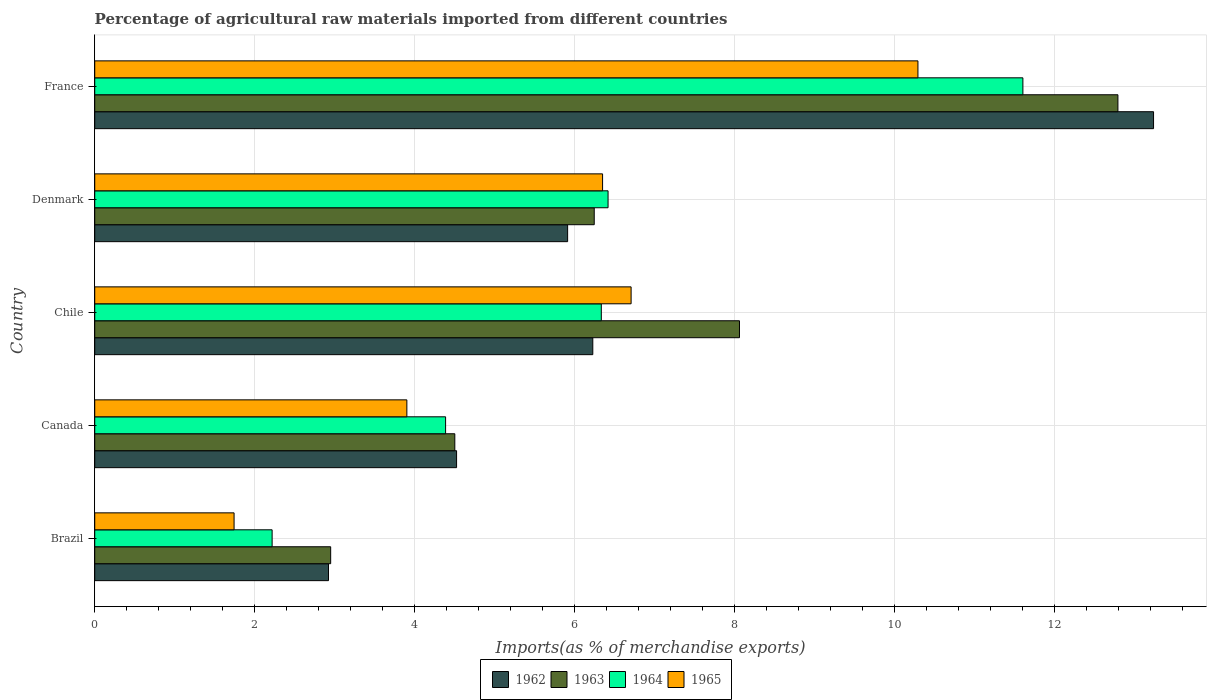How many different coloured bars are there?
Your answer should be very brief. 4. In how many cases, is the number of bars for a given country not equal to the number of legend labels?
Keep it short and to the point. 0. What is the percentage of imports to different countries in 1965 in Brazil?
Your answer should be very brief. 1.74. Across all countries, what is the maximum percentage of imports to different countries in 1964?
Offer a terse response. 11.6. Across all countries, what is the minimum percentage of imports to different countries in 1962?
Your answer should be compact. 2.92. In which country was the percentage of imports to different countries in 1964 minimum?
Give a very brief answer. Brazil. What is the total percentage of imports to different countries in 1963 in the graph?
Your response must be concise. 34.54. What is the difference between the percentage of imports to different countries in 1965 in Brazil and that in Chile?
Your answer should be compact. -4.96. What is the difference between the percentage of imports to different countries in 1965 in France and the percentage of imports to different countries in 1962 in Denmark?
Your response must be concise. 4.38. What is the average percentage of imports to different countries in 1965 per country?
Your answer should be very brief. 5.8. What is the difference between the percentage of imports to different countries in 1964 and percentage of imports to different countries in 1962 in France?
Ensure brevity in your answer.  -1.63. In how many countries, is the percentage of imports to different countries in 1962 greater than 3.2 %?
Your answer should be very brief. 4. What is the ratio of the percentage of imports to different countries in 1962 in Brazil to that in Chile?
Provide a short and direct response. 0.47. What is the difference between the highest and the second highest percentage of imports to different countries in 1964?
Provide a succinct answer. 5.19. What is the difference between the highest and the lowest percentage of imports to different countries in 1963?
Your response must be concise. 9.84. In how many countries, is the percentage of imports to different countries in 1962 greater than the average percentage of imports to different countries in 1962 taken over all countries?
Provide a short and direct response. 1. Is it the case that in every country, the sum of the percentage of imports to different countries in 1965 and percentage of imports to different countries in 1964 is greater than the sum of percentage of imports to different countries in 1962 and percentage of imports to different countries in 1963?
Give a very brief answer. No. What does the 1st bar from the top in France represents?
Offer a very short reply. 1965. How many bars are there?
Provide a succinct answer. 20. Are all the bars in the graph horizontal?
Ensure brevity in your answer.  Yes. How many countries are there in the graph?
Offer a terse response. 5. What is the difference between two consecutive major ticks on the X-axis?
Ensure brevity in your answer.  2. Does the graph contain grids?
Provide a short and direct response. Yes. How are the legend labels stacked?
Your response must be concise. Horizontal. What is the title of the graph?
Give a very brief answer. Percentage of agricultural raw materials imported from different countries. What is the label or title of the X-axis?
Ensure brevity in your answer.  Imports(as % of merchandise exports). What is the Imports(as % of merchandise exports) in 1962 in Brazil?
Offer a very short reply. 2.92. What is the Imports(as % of merchandise exports) in 1963 in Brazil?
Offer a terse response. 2.95. What is the Imports(as % of merchandise exports) in 1964 in Brazil?
Your response must be concise. 2.22. What is the Imports(as % of merchandise exports) of 1965 in Brazil?
Offer a terse response. 1.74. What is the Imports(as % of merchandise exports) of 1962 in Canada?
Offer a terse response. 4.52. What is the Imports(as % of merchandise exports) of 1963 in Canada?
Provide a short and direct response. 4.5. What is the Imports(as % of merchandise exports) in 1964 in Canada?
Provide a short and direct response. 4.39. What is the Imports(as % of merchandise exports) of 1965 in Canada?
Provide a short and direct response. 3.9. What is the Imports(as % of merchandise exports) in 1962 in Chile?
Make the answer very short. 6.23. What is the Imports(as % of merchandise exports) of 1963 in Chile?
Your answer should be very brief. 8.06. What is the Imports(as % of merchandise exports) of 1964 in Chile?
Offer a very short reply. 6.33. What is the Imports(as % of merchandise exports) in 1965 in Chile?
Provide a short and direct response. 6.7. What is the Imports(as % of merchandise exports) of 1962 in Denmark?
Make the answer very short. 5.91. What is the Imports(as % of merchandise exports) in 1963 in Denmark?
Offer a terse response. 6.24. What is the Imports(as % of merchandise exports) in 1964 in Denmark?
Keep it short and to the point. 6.42. What is the Imports(as % of merchandise exports) in 1965 in Denmark?
Your answer should be very brief. 6.35. What is the Imports(as % of merchandise exports) in 1962 in France?
Offer a very short reply. 13.24. What is the Imports(as % of merchandise exports) in 1963 in France?
Provide a succinct answer. 12.79. What is the Imports(as % of merchandise exports) of 1964 in France?
Your answer should be very brief. 11.6. What is the Imports(as % of merchandise exports) of 1965 in France?
Offer a terse response. 10.29. Across all countries, what is the maximum Imports(as % of merchandise exports) of 1962?
Your response must be concise. 13.24. Across all countries, what is the maximum Imports(as % of merchandise exports) of 1963?
Keep it short and to the point. 12.79. Across all countries, what is the maximum Imports(as % of merchandise exports) in 1964?
Provide a succinct answer. 11.6. Across all countries, what is the maximum Imports(as % of merchandise exports) in 1965?
Provide a short and direct response. 10.29. Across all countries, what is the minimum Imports(as % of merchandise exports) of 1962?
Ensure brevity in your answer.  2.92. Across all countries, what is the minimum Imports(as % of merchandise exports) in 1963?
Offer a terse response. 2.95. Across all countries, what is the minimum Imports(as % of merchandise exports) of 1964?
Keep it short and to the point. 2.22. Across all countries, what is the minimum Imports(as % of merchandise exports) of 1965?
Make the answer very short. 1.74. What is the total Imports(as % of merchandise exports) in 1962 in the graph?
Provide a succinct answer. 32.82. What is the total Imports(as % of merchandise exports) in 1963 in the graph?
Provide a short and direct response. 34.54. What is the total Imports(as % of merchandise exports) in 1964 in the graph?
Ensure brevity in your answer.  30.95. What is the total Imports(as % of merchandise exports) of 1965 in the graph?
Ensure brevity in your answer.  28.99. What is the difference between the Imports(as % of merchandise exports) of 1962 in Brazil and that in Canada?
Give a very brief answer. -1.6. What is the difference between the Imports(as % of merchandise exports) of 1963 in Brazil and that in Canada?
Keep it short and to the point. -1.55. What is the difference between the Imports(as % of merchandise exports) in 1964 in Brazil and that in Canada?
Your response must be concise. -2.17. What is the difference between the Imports(as % of merchandise exports) in 1965 in Brazil and that in Canada?
Offer a very short reply. -2.16. What is the difference between the Imports(as % of merchandise exports) in 1962 in Brazil and that in Chile?
Make the answer very short. -3.3. What is the difference between the Imports(as % of merchandise exports) of 1963 in Brazil and that in Chile?
Your answer should be very brief. -5.11. What is the difference between the Imports(as % of merchandise exports) in 1964 in Brazil and that in Chile?
Your answer should be compact. -4.12. What is the difference between the Imports(as % of merchandise exports) in 1965 in Brazil and that in Chile?
Provide a succinct answer. -4.96. What is the difference between the Imports(as % of merchandise exports) of 1962 in Brazil and that in Denmark?
Give a very brief answer. -2.99. What is the difference between the Imports(as % of merchandise exports) of 1963 in Brazil and that in Denmark?
Offer a terse response. -3.29. What is the difference between the Imports(as % of merchandise exports) of 1964 in Brazil and that in Denmark?
Your response must be concise. -4.2. What is the difference between the Imports(as % of merchandise exports) in 1965 in Brazil and that in Denmark?
Give a very brief answer. -4.61. What is the difference between the Imports(as % of merchandise exports) in 1962 in Brazil and that in France?
Provide a succinct answer. -10.31. What is the difference between the Imports(as % of merchandise exports) of 1963 in Brazil and that in France?
Offer a very short reply. -9.84. What is the difference between the Imports(as % of merchandise exports) in 1964 in Brazil and that in France?
Your answer should be compact. -9.38. What is the difference between the Imports(as % of merchandise exports) of 1965 in Brazil and that in France?
Offer a very short reply. -8.55. What is the difference between the Imports(as % of merchandise exports) in 1962 in Canada and that in Chile?
Your answer should be compact. -1.7. What is the difference between the Imports(as % of merchandise exports) of 1963 in Canada and that in Chile?
Your answer should be compact. -3.56. What is the difference between the Imports(as % of merchandise exports) in 1964 in Canada and that in Chile?
Your answer should be very brief. -1.95. What is the difference between the Imports(as % of merchandise exports) in 1965 in Canada and that in Chile?
Your answer should be compact. -2.8. What is the difference between the Imports(as % of merchandise exports) of 1962 in Canada and that in Denmark?
Ensure brevity in your answer.  -1.39. What is the difference between the Imports(as % of merchandise exports) of 1963 in Canada and that in Denmark?
Your answer should be very brief. -1.74. What is the difference between the Imports(as % of merchandise exports) of 1964 in Canada and that in Denmark?
Provide a succinct answer. -2.03. What is the difference between the Imports(as % of merchandise exports) in 1965 in Canada and that in Denmark?
Make the answer very short. -2.45. What is the difference between the Imports(as % of merchandise exports) in 1962 in Canada and that in France?
Your answer should be compact. -8.71. What is the difference between the Imports(as % of merchandise exports) of 1963 in Canada and that in France?
Offer a terse response. -8.29. What is the difference between the Imports(as % of merchandise exports) in 1964 in Canada and that in France?
Provide a short and direct response. -7.22. What is the difference between the Imports(as % of merchandise exports) in 1965 in Canada and that in France?
Make the answer very short. -6.39. What is the difference between the Imports(as % of merchandise exports) of 1962 in Chile and that in Denmark?
Keep it short and to the point. 0.31. What is the difference between the Imports(as % of merchandise exports) of 1963 in Chile and that in Denmark?
Provide a short and direct response. 1.82. What is the difference between the Imports(as % of merchandise exports) in 1964 in Chile and that in Denmark?
Your response must be concise. -0.08. What is the difference between the Imports(as % of merchandise exports) in 1965 in Chile and that in Denmark?
Give a very brief answer. 0.36. What is the difference between the Imports(as % of merchandise exports) in 1962 in Chile and that in France?
Ensure brevity in your answer.  -7.01. What is the difference between the Imports(as % of merchandise exports) of 1963 in Chile and that in France?
Provide a succinct answer. -4.73. What is the difference between the Imports(as % of merchandise exports) in 1964 in Chile and that in France?
Offer a terse response. -5.27. What is the difference between the Imports(as % of merchandise exports) in 1965 in Chile and that in France?
Make the answer very short. -3.59. What is the difference between the Imports(as % of merchandise exports) of 1962 in Denmark and that in France?
Give a very brief answer. -7.32. What is the difference between the Imports(as % of merchandise exports) of 1963 in Denmark and that in France?
Offer a very short reply. -6.55. What is the difference between the Imports(as % of merchandise exports) of 1964 in Denmark and that in France?
Give a very brief answer. -5.19. What is the difference between the Imports(as % of merchandise exports) in 1965 in Denmark and that in France?
Give a very brief answer. -3.94. What is the difference between the Imports(as % of merchandise exports) in 1962 in Brazil and the Imports(as % of merchandise exports) in 1963 in Canada?
Provide a succinct answer. -1.58. What is the difference between the Imports(as % of merchandise exports) of 1962 in Brazil and the Imports(as % of merchandise exports) of 1964 in Canada?
Make the answer very short. -1.46. What is the difference between the Imports(as % of merchandise exports) of 1962 in Brazil and the Imports(as % of merchandise exports) of 1965 in Canada?
Offer a terse response. -0.98. What is the difference between the Imports(as % of merchandise exports) in 1963 in Brazil and the Imports(as % of merchandise exports) in 1964 in Canada?
Offer a very short reply. -1.44. What is the difference between the Imports(as % of merchandise exports) of 1963 in Brazil and the Imports(as % of merchandise exports) of 1965 in Canada?
Your answer should be compact. -0.95. What is the difference between the Imports(as % of merchandise exports) of 1964 in Brazil and the Imports(as % of merchandise exports) of 1965 in Canada?
Give a very brief answer. -1.68. What is the difference between the Imports(as % of merchandise exports) in 1962 in Brazil and the Imports(as % of merchandise exports) in 1963 in Chile?
Provide a succinct answer. -5.14. What is the difference between the Imports(as % of merchandise exports) in 1962 in Brazil and the Imports(as % of merchandise exports) in 1964 in Chile?
Your answer should be very brief. -3.41. What is the difference between the Imports(as % of merchandise exports) of 1962 in Brazil and the Imports(as % of merchandise exports) of 1965 in Chile?
Your answer should be compact. -3.78. What is the difference between the Imports(as % of merchandise exports) in 1963 in Brazil and the Imports(as % of merchandise exports) in 1964 in Chile?
Provide a short and direct response. -3.38. What is the difference between the Imports(as % of merchandise exports) in 1963 in Brazil and the Imports(as % of merchandise exports) in 1965 in Chile?
Offer a very short reply. -3.76. What is the difference between the Imports(as % of merchandise exports) of 1964 in Brazil and the Imports(as % of merchandise exports) of 1965 in Chile?
Keep it short and to the point. -4.49. What is the difference between the Imports(as % of merchandise exports) in 1962 in Brazil and the Imports(as % of merchandise exports) in 1963 in Denmark?
Ensure brevity in your answer.  -3.32. What is the difference between the Imports(as % of merchandise exports) of 1962 in Brazil and the Imports(as % of merchandise exports) of 1964 in Denmark?
Make the answer very short. -3.49. What is the difference between the Imports(as % of merchandise exports) of 1962 in Brazil and the Imports(as % of merchandise exports) of 1965 in Denmark?
Your answer should be very brief. -3.43. What is the difference between the Imports(as % of merchandise exports) of 1963 in Brazil and the Imports(as % of merchandise exports) of 1964 in Denmark?
Provide a succinct answer. -3.47. What is the difference between the Imports(as % of merchandise exports) in 1963 in Brazil and the Imports(as % of merchandise exports) in 1965 in Denmark?
Offer a very short reply. -3.4. What is the difference between the Imports(as % of merchandise exports) of 1964 in Brazil and the Imports(as % of merchandise exports) of 1965 in Denmark?
Make the answer very short. -4.13. What is the difference between the Imports(as % of merchandise exports) in 1962 in Brazil and the Imports(as % of merchandise exports) in 1963 in France?
Provide a succinct answer. -9.87. What is the difference between the Imports(as % of merchandise exports) of 1962 in Brazil and the Imports(as % of merchandise exports) of 1964 in France?
Give a very brief answer. -8.68. What is the difference between the Imports(as % of merchandise exports) of 1962 in Brazil and the Imports(as % of merchandise exports) of 1965 in France?
Your response must be concise. -7.37. What is the difference between the Imports(as % of merchandise exports) of 1963 in Brazil and the Imports(as % of merchandise exports) of 1964 in France?
Provide a short and direct response. -8.65. What is the difference between the Imports(as % of merchandise exports) of 1963 in Brazil and the Imports(as % of merchandise exports) of 1965 in France?
Give a very brief answer. -7.34. What is the difference between the Imports(as % of merchandise exports) in 1964 in Brazil and the Imports(as % of merchandise exports) in 1965 in France?
Your response must be concise. -8.07. What is the difference between the Imports(as % of merchandise exports) in 1962 in Canada and the Imports(as % of merchandise exports) in 1963 in Chile?
Your answer should be compact. -3.54. What is the difference between the Imports(as % of merchandise exports) in 1962 in Canada and the Imports(as % of merchandise exports) in 1964 in Chile?
Ensure brevity in your answer.  -1.81. What is the difference between the Imports(as % of merchandise exports) of 1962 in Canada and the Imports(as % of merchandise exports) of 1965 in Chile?
Provide a succinct answer. -2.18. What is the difference between the Imports(as % of merchandise exports) in 1963 in Canada and the Imports(as % of merchandise exports) in 1964 in Chile?
Keep it short and to the point. -1.83. What is the difference between the Imports(as % of merchandise exports) of 1963 in Canada and the Imports(as % of merchandise exports) of 1965 in Chile?
Give a very brief answer. -2.2. What is the difference between the Imports(as % of merchandise exports) in 1964 in Canada and the Imports(as % of merchandise exports) in 1965 in Chile?
Provide a succinct answer. -2.32. What is the difference between the Imports(as % of merchandise exports) of 1962 in Canada and the Imports(as % of merchandise exports) of 1963 in Denmark?
Make the answer very short. -1.72. What is the difference between the Imports(as % of merchandise exports) in 1962 in Canada and the Imports(as % of merchandise exports) in 1964 in Denmark?
Offer a terse response. -1.89. What is the difference between the Imports(as % of merchandise exports) of 1962 in Canada and the Imports(as % of merchandise exports) of 1965 in Denmark?
Give a very brief answer. -1.83. What is the difference between the Imports(as % of merchandise exports) of 1963 in Canada and the Imports(as % of merchandise exports) of 1964 in Denmark?
Give a very brief answer. -1.92. What is the difference between the Imports(as % of merchandise exports) in 1963 in Canada and the Imports(as % of merchandise exports) in 1965 in Denmark?
Offer a very short reply. -1.85. What is the difference between the Imports(as % of merchandise exports) in 1964 in Canada and the Imports(as % of merchandise exports) in 1965 in Denmark?
Offer a terse response. -1.96. What is the difference between the Imports(as % of merchandise exports) in 1962 in Canada and the Imports(as % of merchandise exports) in 1963 in France?
Provide a short and direct response. -8.27. What is the difference between the Imports(as % of merchandise exports) of 1962 in Canada and the Imports(as % of merchandise exports) of 1964 in France?
Your answer should be compact. -7.08. What is the difference between the Imports(as % of merchandise exports) in 1962 in Canada and the Imports(as % of merchandise exports) in 1965 in France?
Ensure brevity in your answer.  -5.77. What is the difference between the Imports(as % of merchandise exports) of 1963 in Canada and the Imports(as % of merchandise exports) of 1964 in France?
Offer a very short reply. -7.1. What is the difference between the Imports(as % of merchandise exports) of 1963 in Canada and the Imports(as % of merchandise exports) of 1965 in France?
Make the answer very short. -5.79. What is the difference between the Imports(as % of merchandise exports) of 1964 in Canada and the Imports(as % of merchandise exports) of 1965 in France?
Make the answer very short. -5.9. What is the difference between the Imports(as % of merchandise exports) in 1962 in Chile and the Imports(as % of merchandise exports) in 1963 in Denmark?
Provide a short and direct response. -0.02. What is the difference between the Imports(as % of merchandise exports) in 1962 in Chile and the Imports(as % of merchandise exports) in 1964 in Denmark?
Give a very brief answer. -0.19. What is the difference between the Imports(as % of merchandise exports) of 1962 in Chile and the Imports(as % of merchandise exports) of 1965 in Denmark?
Your answer should be compact. -0.12. What is the difference between the Imports(as % of merchandise exports) in 1963 in Chile and the Imports(as % of merchandise exports) in 1964 in Denmark?
Ensure brevity in your answer.  1.64. What is the difference between the Imports(as % of merchandise exports) in 1963 in Chile and the Imports(as % of merchandise exports) in 1965 in Denmark?
Offer a terse response. 1.71. What is the difference between the Imports(as % of merchandise exports) in 1964 in Chile and the Imports(as % of merchandise exports) in 1965 in Denmark?
Offer a terse response. -0.02. What is the difference between the Imports(as % of merchandise exports) of 1962 in Chile and the Imports(as % of merchandise exports) of 1963 in France?
Offer a very short reply. -6.56. What is the difference between the Imports(as % of merchandise exports) of 1962 in Chile and the Imports(as % of merchandise exports) of 1964 in France?
Keep it short and to the point. -5.38. What is the difference between the Imports(as % of merchandise exports) of 1962 in Chile and the Imports(as % of merchandise exports) of 1965 in France?
Provide a succinct answer. -4.06. What is the difference between the Imports(as % of merchandise exports) in 1963 in Chile and the Imports(as % of merchandise exports) in 1964 in France?
Provide a succinct answer. -3.54. What is the difference between the Imports(as % of merchandise exports) in 1963 in Chile and the Imports(as % of merchandise exports) in 1965 in France?
Give a very brief answer. -2.23. What is the difference between the Imports(as % of merchandise exports) of 1964 in Chile and the Imports(as % of merchandise exports) of 1965 in France?
Provide a short and direct response. -3.96. What is the difference between the Imports(as % of merchandise exports) of 1962 in Denmark and the Imports(as % of merchandise exports) of 1963 in France?
Offer a terse response. -6.88. What is the difference between the Imports(as % of merchandise exports) of 1962 in Denmark and the Imports(as % of merchandise exports) of 1964 in France?
Keep it short and to the point. -5.69. What is the difference between the Imports(as % of merchandise exports) of 1962 in Denmark and the Imports(as % of merchandise exports) of 1965 in France?
Your answer should be compact. -4.38. What is the difference between the Imports(as % of merchandise exports) in 1963 in Denmark and the Imports(as % of merchandise exports) in 1964 in France?
Your answer should be compact. -5.36. What is the difference between the Imports(as % of merchandise exports) in 1963 in Denmark and the Imports(as % of merchandise exports) in 1965 in France?
Your answer should be very brief. -4.05. What is the difference between the Imports(as % of merchandise exports) of 1964 in Denmark and the Imports(as % of merchandise exports) of 1965 in France?
Make the answer very short. -3.87. What is the average Imports(as % of merchandise exports) of 1962 per country?
Your answer should be compact. 6.56. What is the average Imports(as % of merchandise exports) of 1963 per country?
Ensure brevity in your answer.  6.91. What is the average Imports(as % of merchandise exports) of 1964 per country?
Your answer should be very brief. 6.19. What is the average Imports(as % of merchandise exports) in 1965 per country?
Your response must be concise. 5.8. What is the difference between the Imports(as % of merchandise exports) of 1962 and Imports(as % of merchandise exports) of 1963 in Brazil?
Offer a very short reply. -0.03. What is the difference between the Imports(as % of merchandise exports) in 1962 and Imports(as % of merchandise exports) in 1964 in Brazil?
Your response must be concise. 0.7. What is the difference between the Imports(as % of merchandise exports) in 1962 and Imports(as % of merchandise exports) in 1965 in Brazil?
Ensure brevity in your answer.  1.18. What is the difference between the Imports(as % of merchandise exports) of 1963 and Imports(as % of merchandise exports) of 1964 in Brazil?
Provide a succinct answer. 0.73. What is the difference between the Imports(as % of merchandise exports) in 1963 and Imports(as % of merchandise exports) in 1965 in Brazil?
Offer a terse response. 1.21. What is the difference between the Imports(as % of merchandise exports) in 1964 and Imports(as % of merchandise exports) in 1965 in Brazil?
Offer a terse response. 0.48. What is the difference between the Imports(as % of merchandise exports) in 1962 and Imports(as % of merchandise exports) in 1963 in Canada?
Ensure brevity in your answer.  0.02. What is the difference between the Imports(as % of merchandise exports) of 1962 and Imports(as % of merchandise exports) of 1964 in Canada?
Your answer should be compact. 0.14. What is the difference between the Imports(as % of merchandise exports) of 1962 and Imports(as % of merchandise exports) of 1965 in Canada?
Keep it short and to the point. 0.62. What is the difference between the Imports(as % of merchandise exports) in 1963 and Imports(as % of merchandise exports) in 1964 in Canada?
Give a very brief answer. 0.12. What is the difference between the Imports(as % of merchandise exports) of 1963 and Imports(as % of merchandise exports) of 1965 in Canada?
Your answer should be very brief. 0.6. What is the difference between the Imports(as % of merchandise exports) in 1964 and Imports(as % of merchandise exports) in 1965 in Canada?
Offer a terse response. 0.48. What is the difference between the Imports(as % of merchandise exports) in 1962 and Imports(as % of merchandise exports) in 1963 in Chile?
Offer a terse response. -1.83. What is the difference between the Imports(as % of merchandise exports) of 1962 and Imports(as % of merchandise exports) of 1964 in Chile?
Give a very brief answer. -0.11. What is the difference between the Imports(as % of merchandise exports) in 1962 and Imports(as % of merchandise exports) in 1965 in Chile?
Your response must be concise. -0.48. What is the difference between the Imports(as % of merchandise exports) of 1963 and Imports(as % of merchandise exports) of 1964 in Chile?
Your answer should be compact. 1.73. What is the difference between the Imports(as % of merchandise exports) of 1963 and Imports(as % of merchandise exports) of 1965 in Chile?
Keep it short and to the point. 1.35. What is the difference between the Imports(as % of merchandise exports) of 1964 and Imports(as % of merchandise exports) of 1965 in Chile?
Give a very brief answer. -0.37. What is the difference between the Imports(as % of merchandise exports) of 1962 and Imports(as % of merchandise exports) of 1963 in Denmark?
Your answer should be very brief. -0.33. What is the difference between the Imports(as % of merchandise exports) of 1962 and Imports(as % of merchandise exports) of 1964 in Denmark?
Give a very brief answer. -0.51. What is the difference between the Imports(as % of merchandise exports) of 1962 and Imports(as % of merchandise exports) of 1965 in Denmark?
Make the answer very short. -0.44. What is the difference between the Imports(as % of merchandise exports) of 1963 and Imports(as % of merchandise exports) of 1964 in Denmark?
Ensure brevity in your answer.  -0.17. What is the difference between the Imports(as % of merchandise exports) of 1963 and Imports(as % of merchandise exports) of 1965 in Denmark?
Provide a succinct answer. -0.1. What is the difference between the Imports(as % of merchandise exports) of 1964 and Imports(as % of merchandise exports) of 1965 in Denmark?
Your response must be concise. 0.07. What is the difference between the Imports(as % of merchandise exports) of 1962 and Imports(as % of merchandise exports) of 1963 in France?
Keep it short and to the point. 0.45. What is the difference between the Imports(as % of merchandise exports) in 1962 and Imports(as % of merchandise exports) in 1964 in France?
Provide a short and direct response. 1.63. What is the difference between the Imports(as % of merchandise exports) of 1962 and Imports(as % of merchandise exports) of 1965 in France?
Make the answer very short. 2.95. What is the difference between the Imports(as % of merchandise exports) of 1963 and Imports(as % of merchandise exports) of 1964 in France?
Give a very brief answer. 1.19. What is the difference between the Imports(as % of merchandise exports) of 1963 and Imports(as % of merchandise exports) of 1965 in France?
Make the answer very short. 2.5. What is the difference between the Imports(as % of merchandise exports) of 1964 and Imports(as % of merchandise exports) of 1965 in France?
Provide a short and direct response. 1.31. What is the ratio of the Imports(as % of merchandise exports) of 1962 in Brazil to that in Canada?
Ensure brevity in your answer.  0.65. What is the ratio of the Imports(as % of merchandise exports) in 1963 in Brazil to that in Canada?
Give a very brief answer. 0.66. What is the ratio of the Imports(as % of merchandise exports) of 1964 in Brazil to that in Canada?
Provide a short and direct response. 0.51. What is the ratio of the Imports(as % of merchandise exports) in 1965 in Brazil to that in Canada?
Make the answer very short. 0.45. What is the ratio of the Imports(as % of merchandise exports) in 1962 in Brazil to that in Chile?
Give a very brief answer. 0.47. What is the ratio of the Imports(as % of merchandise exports) of 1963 in Brazil to that in Chile?
Keep it short and to the point. 0.37. What is the ratio of the Imports(as % of merchandise exports) in 1964 in Brazil to that in Chile?
Offer a terse response. 0.35. What is the ratio of the Imports(as % of merchandise exports) of 1965 in Brazil to that in Chile?
Offer a very short reply. 0.26. What is the ratio of the Imports(as % of merchandise exports) of 1962 in Brazil to that in Denmark?
Offer a very short reply. 0.49. What is the ratio of the Imports(as % of merchandise exports) in 1963 in Brazil to that in Denmark?
Provide a short and direct response. 0.47. What is the ratio of the Imports(as % of merchandise exports) in 1964 in Brazil to that in Denmark?
Your response must be concise. 0.35. What is the ratio of the Imports(as % of merchandise exports) in 1965 in Brazil to that in Denmark?
Make the answer very short. 0.27. What is the ratio of the Imports(as % of merchandise exports) in 1962 in Brazil to that in France?
Make the answer very short. 0.22. What is the ratio of the Imports(as % of merchandise exports) of 1963 in Brazil to that in France?
Provide a short and direct response. 0.23. What is the ratio of the Imports(as % of merchandise exports) in 1964 in Brazil to that in France?
Make the answer very short. 0.19. What is the ratio of the Imports(as % of merchandise exports) in 1965 in Brazil to that in France?
Offer a very short reply. 0.17. What is the ratio of the Imports(as % of merchandise exports) of 1962 in Canada to that in Chile?
Offer a terse response. 0.73. What is the ratio of the Imports(as % of merchandise exports) in 1963 in Canada to that in Chile?
Your answer should be compact. 0.56. What is the ratio of the Imports(as % of merchandise exports) in 1964 in Canada to that in Chile?
Your answer should be very brief. 0.69. What is the ratio of the Imports(as % of merchandise exports) in 1965 in Canada to that in Chile?
Your response must be concise. 0.58. What is the ratio of the Imports(as % of merchandise exports) of 1962 in Canada to that in Denmark?
Ensure brevity in your answer.  0.77. What is the ratio of the Imports(as % of merchandise exports) in 1963 in Canada to that in Denmark?
Provide a succinct answer. 0.72. What is the ratio of the Imports(as % of merchandise exports) of 1964 in Canada to that in Denmark?
Your answer should be compact. 0.68. What is the ratio of the Imports(as % of merchandise exports) of 1965 in Canada to that in Denmark?
Your response must be concise. 0.61. What is the ratio of the Imports(as % of merchandise exports) in 1962 in Canada to that in France?
Offer a terse response. 0.34. What is the ratio of the Imports(as % of merchandise exports) of 1963 in Canada to that in France?
Keep it short and to the point. 0.35. What is the ratio of the Imports(as % of merchandise exports) in 1964 in Canada to that in France?
Offer a very short reply. 0.38. What is the ratio of the Imports(as % of merchandise exports) in 1965 in Canada to that in France?
Provide a short and direct response. 0.38. What is the ratio of the Imports(as % of merchandise exports) in 1962 in Chile to that in Denmark?
Offer a very short reply. 1.05. What is the ratio of the Imports(as % of merchandise exports) in 1963 in Chile to that in Denmark?
Make the answer very short. 1.29. What is the ratio of the Imports(as % of merchandise exports) of 1964 in Chile to that in Denmark?
Your response must be concise. 0.99. What is the ratio of the Imports(as % of merchandise exports) in 1965 in Chile to that in Denmark?
Make the answer very short. 1.06. What is the ratio of the Imports(as % of merchandise exports) of 1962 in Chile to that in France?
Offer a very short reply. 0.47. What is the ratio of the Imports(as % of merchandise exports) in 1963 in Chile to that in France?
Ensure brevity in your answer.  0.63. What is the ratio of the Imports(as % of merchandise exports) in 1964 in Chile to that in France?
Make the answer very short. 0.55. What is the ratio of the Imports(as % of merchandise exports) in 1965 in Chile to that in France?
Provide a succinct answer. 0.65. What is the ratio of the Imports(as % of merchandise exports) in 1962 in Denmark to that in France?
Provide a succinct answer. 0.45. What is the ratio of the Imports(as % of merchandise exports) in 1963 in Denmark to that in France?
Your answer should be compact. 0.49. What is the ratio of the Imports(as % of merchandise exports) of 1964 in Denmark to that in France?
Provide a short and direct response. 0.55. What is the ratio of the Imports(as % of merchandise exports) in 1965 in Denmark to that in France?
Offer a very short reply. 0.62. What is the difference between the highest and the second highest Imports(as % of merchandise exports) in 1962?
Keep it short and to the point. 7.01. What is the difference between the highest and the second highest Imports(as % of merchandise exports) of 1963?
Make the answer very short. 4.73. What is the difference between the highest and the second highest Imports(as % of merchandise exports) of 1964?
Provide a succinct answer. 5.19. What is the difference between the highest and the second highest Imports(as % of merchandise exports) in 1965?
Your answer should be compact. 3.59. What is the difference between the highest and the lowest Imports(as % of merchandise exports) in 1962?
Ensure brevity in your answer.  10.31. What is the difference between the highest and the lowest Imports(as % of merchandise exports) of 1963?
Provide a short and direct response. 9.84. What is the difference between the highest and the lowest Imports(as % of merchandise exports) of 1964?
Make the answer very short. 9.38. What is the difference between the highest and the lowest Imports(as % of merchandise exports) of 1965?
Your answer should be very brief. 8.55. 